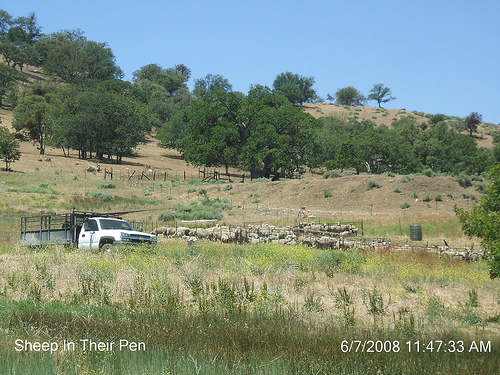<image>
Is the truck behind the barrel? No. The truck is not behind the barrel. From this viewpoint, the truck appears to be positioned elsewhere in the scene. 